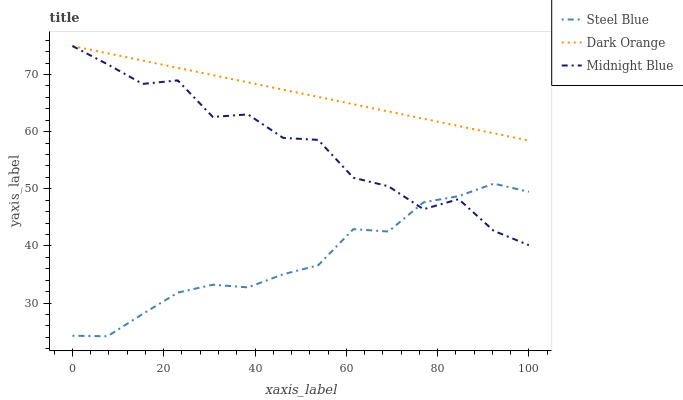Does Steel Blue have the minimum area under the curve?
Answer yes or no. Yes. Does Dark Orange have the maximum area under the curve?
Answer yes or no. Yes. Does Midnight Blue have the minimum area under the curve?
Answer yes or no. No. Does Midnight Blue have the maximum area under the curve?
Answer yes or no. No. Is Dark Orange the smoothest?
Answer yes or no. Yes. Is Midnight Blue the roughest?
Answer yes or no. Yes. Is Steel Blue the smoothest?
Answer yes or no. No. Is Steel Blue the roughest?
Answer yes or no. No. Does Steel Blue have the lowest value?
Answer yes or no. Yes. Does Midnight Blue have the lowest value?
Answer yes or no. No. Does Midnight Blue have the highest value?
Answer yes or no. Yes. Does Steel Blue have the highest value?
Answer yes or no. No. Is Steel Blue less than Dark Orange?
Answer yes or no. Yes. Is Dark Orange greater than Steel Blue?
Answer yes or no. Yes. Does Midnight Blue intersect Dark Orange?
Answer yes or no. Yes. Is Midnight Blue less than Dark Orange?
Answer yes or no. No. Is Midnight Blue greater than Dark Orange?
Answer yes or no. No. Does Steel Blue intersect Dark Orange?
Answer yes or no. No. 